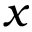Convert formula to latex. <formula><loc_0><loc_0><loc_500><loc_500>x</formula> 